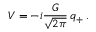<formula> <loc_0><loc_0><loc_500><loc_500>V = - i \frac { G } { \sqrt { 2 \pi } } \, q _ { + } \, .</formula> 